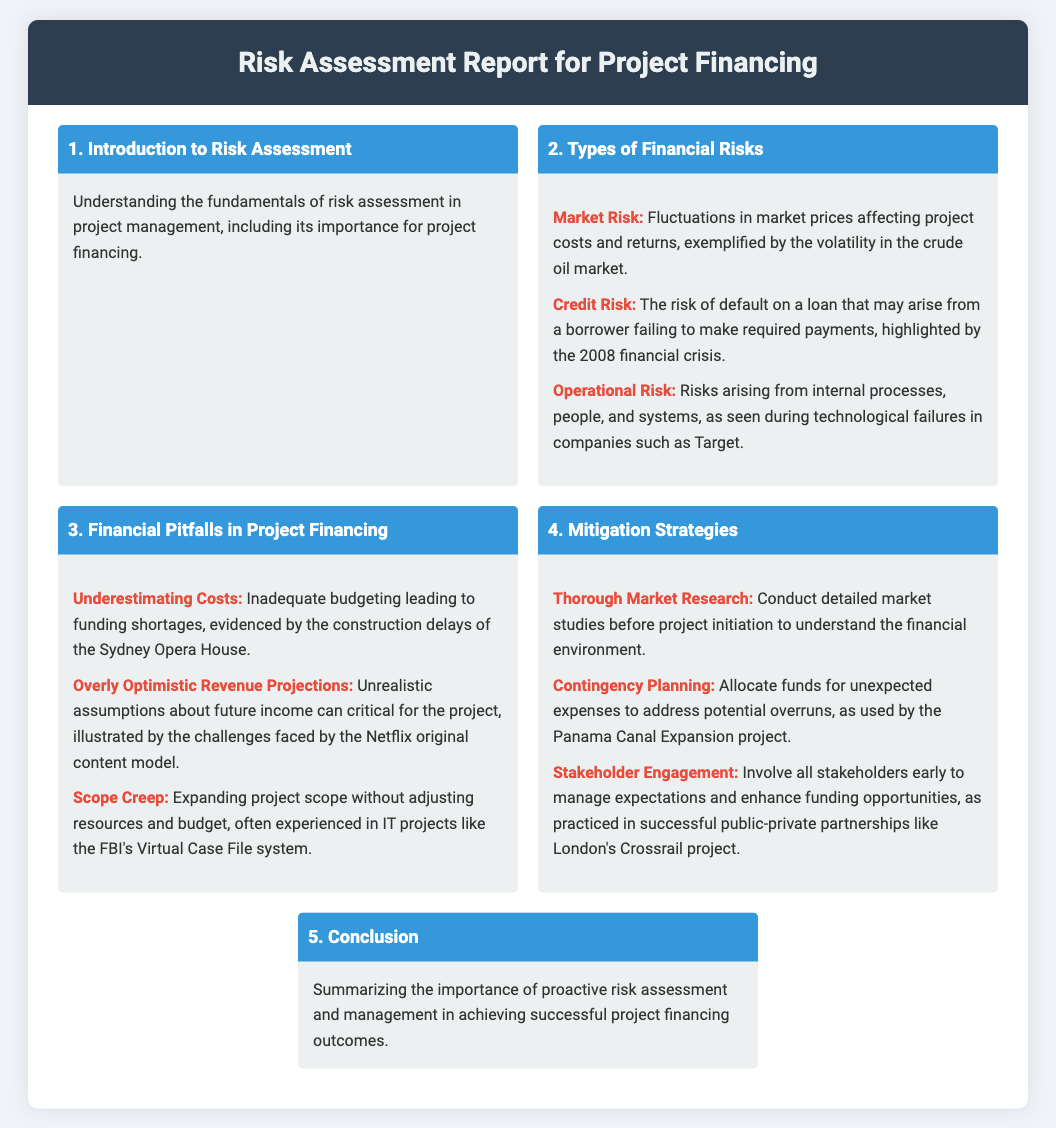What is the title of the document? The title of the document can be found in the header section, which states "Risk Assessment Report for Project Financing."
Answer: Risk Assessment Report for Project Financing What is one type of financial risk mentioned? Specific types of financial risks are listed in the "Types of Financial Risks" section, one of which is "Market Risk."
Answer: Market Risk What financial pitfall is related to budgeting? The financial pitfalls associated with budgeting can be found in the section labeled "Financial Pitfalls in Project Financing," referring specifically to "Underestimating Costs."
Answer: Underestimating Costs Which mitigation strategy involves involving stakeholders? The mitigation strategies section lists several strategies, one of which includes "Stakeholder Engagement."
Answer: Stakeholder Engagement What was a notable example of operational risk? The document provides an example of operational risk in the context of internal failures, specifically citing "Target."
Answer: Target What is highlighted as a mitigation strategy for unexpected expenses? In the mitigation strategies section, a specific strategy for unexpected expenses is "Contingency Planning."
Answer: Contingency Planning How many sections are in the document? The document consists of several sections, counting them yields a total of five sections.
Answer: 5 What year is referenced in relation to credit risk? The document references the financial crisis that occurred in "2008" regarding credit risk.
Answer: 2008 What project is mentioned in relation to scope creep? Scope creep is illustrated with the example of the "FBI's Virtual Case File system."
Answer: FBI's Virtual Case File system 